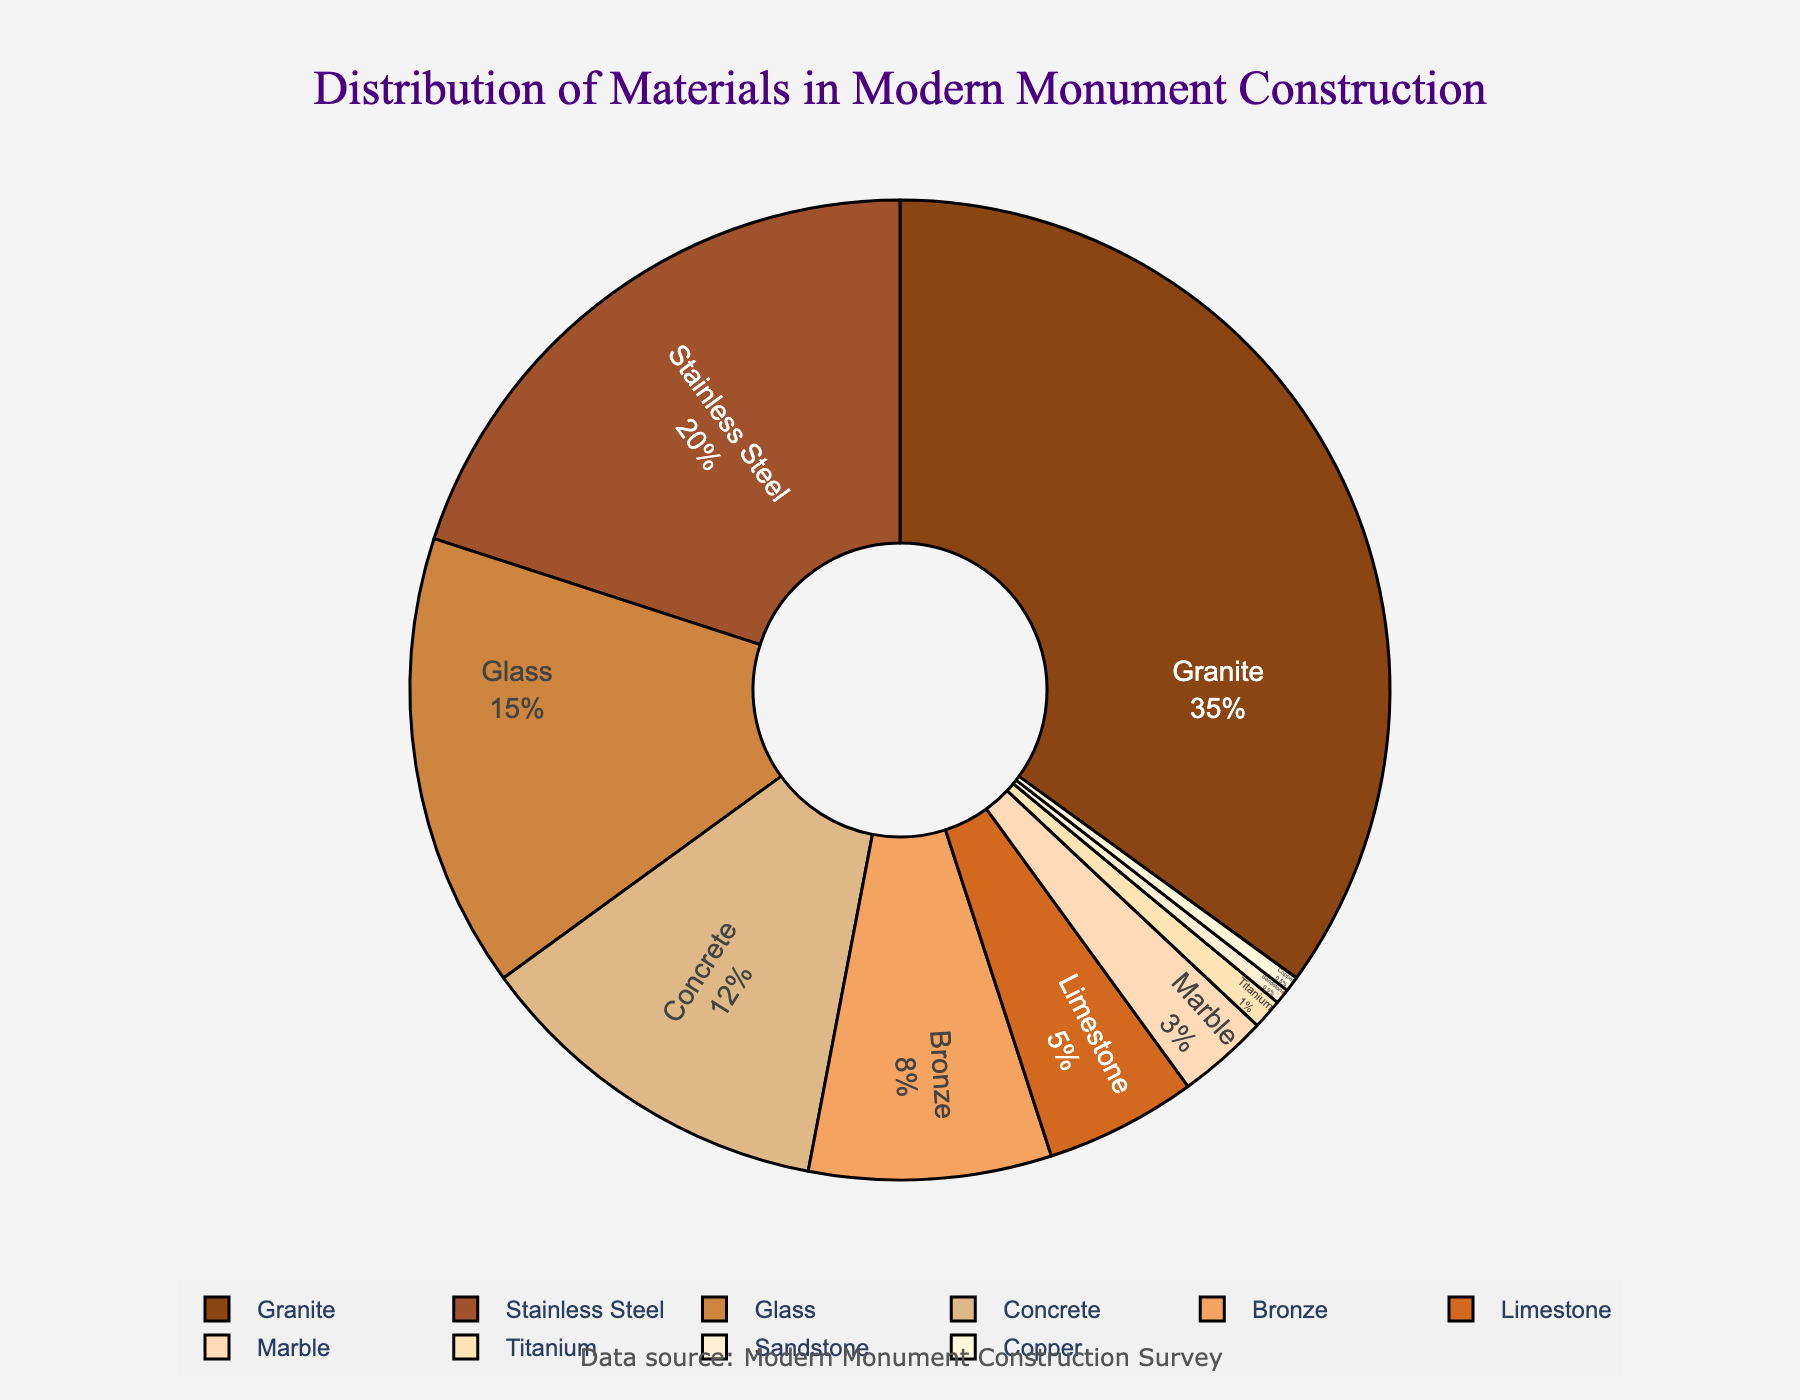Which material has the smallest percentage? The material with the smallest percentage is identified by looking at the segments of the pie chart. Sandstone and Copper both have the smallest percentages, with each having a proportion of 0.5%.
Answer: Sandstone and Copper What is the combined percentage of Concrete and Bronze? To find the combined percentage, look at the individual percentages for Concrete (12%) and Bronze (8%) and add them together. 12% + 8% = 20%
Answer: 20% Which materials constitute more than 30% of the construction materials? Identify the materials whose segments in the pie chart sum up to more than 30%. The sum of Granite's percentage alone is 35%, which is greater than 30%.
Answer: Granite How many materials have a percentage greater than or equal to 10%? Count the segments in the pie chart that have a percentage value of 10% or more. The materials are Granite (35%), Stainless Steel (20%), Glass (15%), and Concrete (12%). Thus, there are 4 materials.
Answer: 4 What is the percentage difference between the most used and the least used material? Subtract the percentage of the least used material (0.5% for Sandstone or Copper) from the percentage of the most used material (35% for Granite). 35% - 0.5% = 34.5%
Answer: 34.5% Which material has more percentage use: Limestone or Stainless Steel? Compare the segments representing Limestone (5%) and Stainless Steel (20%) in the pie chart. Stainless Steel has a higher percentage than Limestone.
Answer: Stainless Steel What is the percentage of materials other than Granite and Stainless Steel? Subtract the percentages of Granite (35%) and Stainless Steel (20%) from 100%. 100% - 35% - 20% = 45%
Answer: 45% How does the combined percentage of Glass, Bronze, Marble, and Titanium compare to the percentage of Granite? First, add the percentages of Glass (15%), Bronze (8%), Marble (3%), and Titanium (1%), which equals 27%. Then compare this to 35% for Granite. 27% < 35%
Answer: Less Is the percentage usage of Bronze more than twice that of Limestone? Check if 8% (Bronze) is more than twice the 5% (Limestone). Twice the usage of Limestone is 10%, and 8% is not more than 10%.
Answer: No 